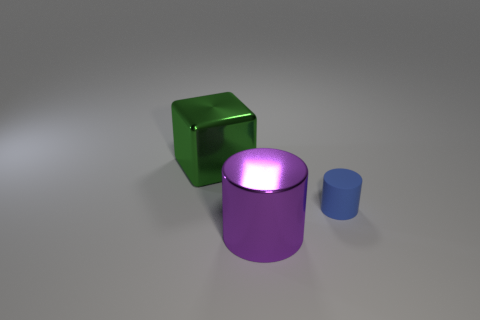Is there anything else that is the same size as the matte cylinder?
Your response must be concise. No. Is the number of things in front of the large purple cylinder greater than the number of small blue cylinders to the right of the small object?
Your response must be concise. No. What number of other things are there of the same material as the purple cylinder
Your answer should be compact. 1. Do the big thing that is to the right of the big metallic block and the small blue object have the same material?
Give a very brief answer. No. What shape is the green object?
Offer a very short reply. Cube. Is the number of purple objects that are on the left side of the green metal object greater than the number of big gray cubes?
Keep it short and to the point. No. Is there anything else that has the same shape as the small blue object?
Your response must be concise. Yes. There is another big object that is the same shape as the blue object; what is its color?
Make the answer very short. Purple. What shape is the large metallic thing that is behind the rubber object?
Your response must be concise. Cube. Are there any small rubber cylinders on the left side of the large purple metal object?
Make the answer very short. No. 